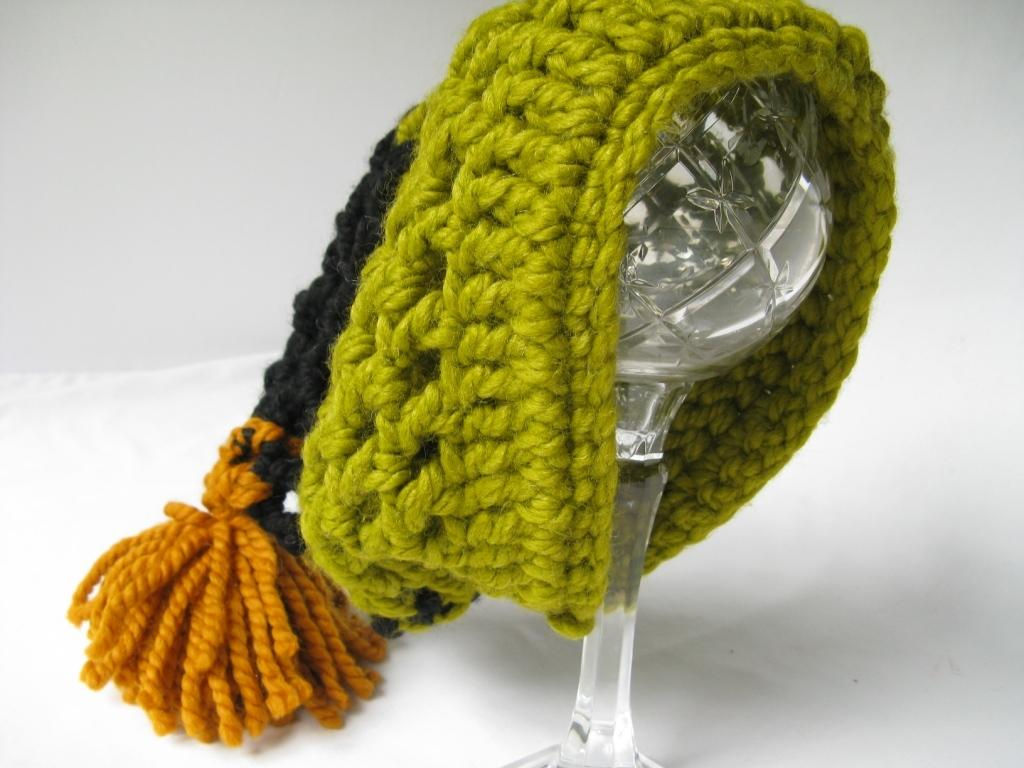What type of furniture is present in the image? There is a table in the image. What object is placed on the table? There is a glass in the image. What is covering the glass? The glass is covered with a woolen cap. What type of net is used to catch the rays in the image? There is no net or rays present in the image; it features a table with a glass covered by a woolen cap. 